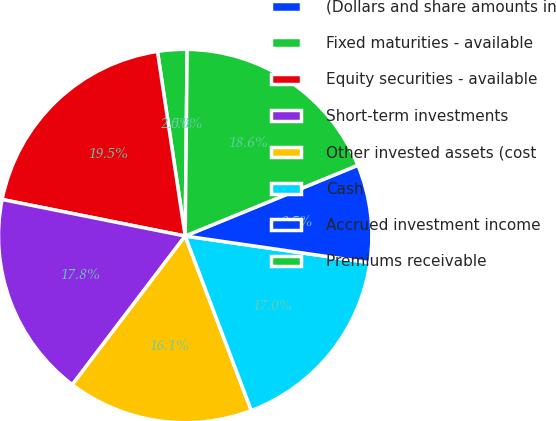Convert chart. <chart><loc_0><loc_0><loc_500><loc_500><pie_chart><fcel>(Dollars and share amounts in<fcel>Fixed maturities - available<fcel>Equity securities - available<fcel>Short-term investments<fcel>Other invested assets (cost<fcel>Cash<fcel>Accrued investment income<fcel>Premiums receivable<nl><fcel>0.0%<fcel>2.54%<fcel>19.49%<fcel>17.8%<fcel>16.1%<fcel>16.95%<fcel>8.47%<fcel>18.64%<nl></chart> 